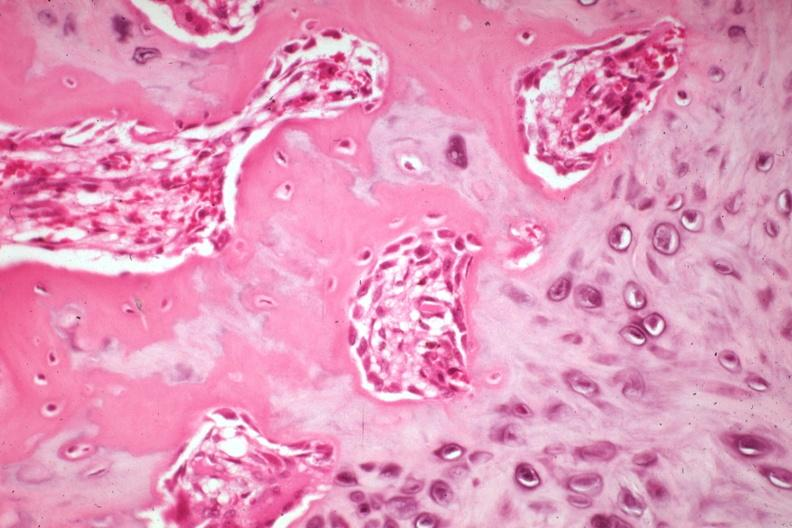s joints present?
Answer the question using a single word or phrase. Yes 